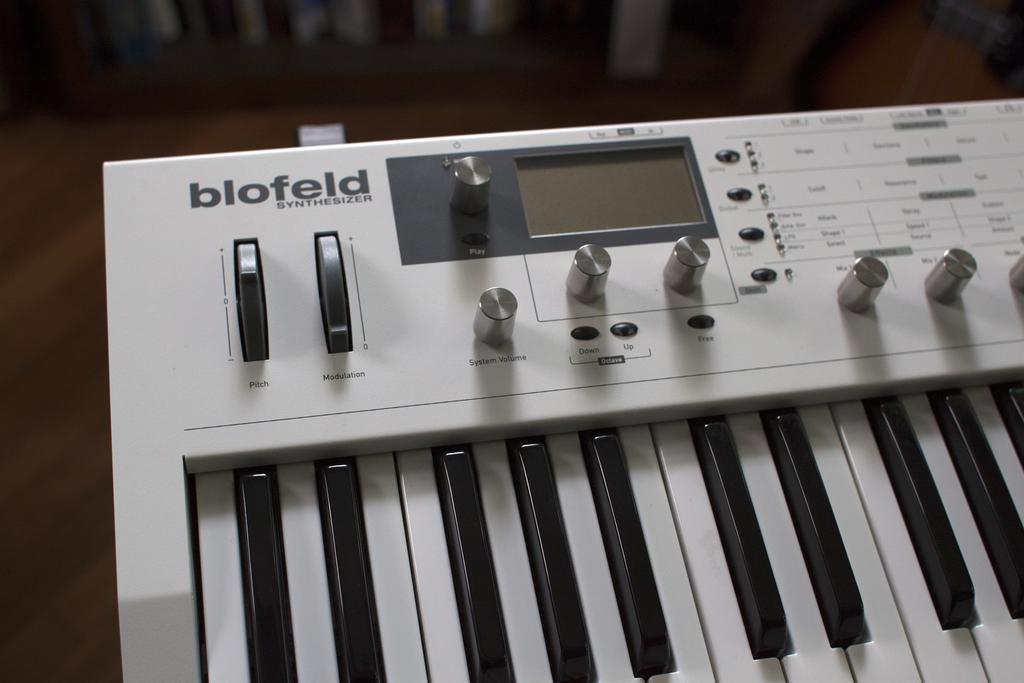What object in the image is associated with music? There is a musical instrument in the image. Can you describe the background of the image? The background of the image is blurred. What type of cannon is present in the image? There is no cannon present in the image; it features a musical instrument. Can you describe the level of detail in the vase in the image? There is no vase present in the image; it only features a musical instrument and a blurred background. 